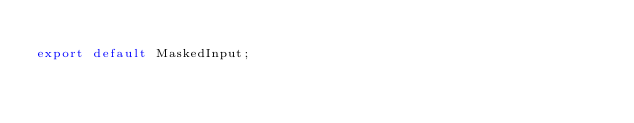Convert code to text. <code><loc_0><loc_0><loc_500><loc_500><_TypeScript_>
export default MaskedInput;
</code> 